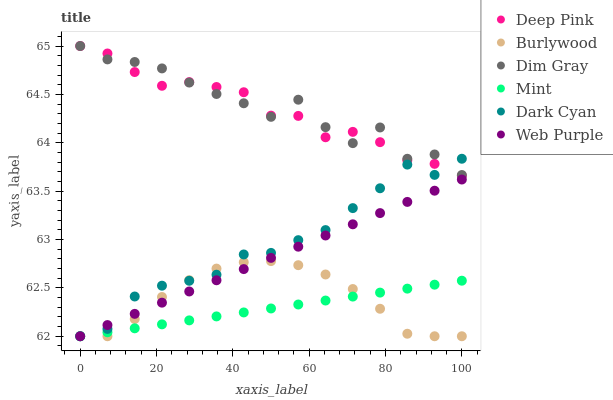Does Mint have the minimum area under the curve?
Answer yes or no. Yes. Does Dim Gray have the maximum area under the curve?
Answer yes or no. Yes. Does Burlywood have the minimum area under the curve?
Answer yes or no. No. Does Burlywood have the maximum area under the curve?
Answer yes or no. No. Is Mint the smoothest?
Answer yes or no. Yes. Is Dim Gray the roughest?
Answer yes or no. Yes. Is Burlywood the smoothest?
Answer yes or no. No. Is Burlywood the roughest?
Answer yes or no. No. Does Burlywood have the lowest value?
Answer yes or no. Yes. Does Deep Pink have the lowest value?
Answer yes or no. No. Does Deep Pink have the highest value?
Answer yes or no. Yes. Does Burlywood have the highest value?
Answer yes or no. No. Is Web Purple less than Deep Pink?
Answer yes or no. Yes. Is Deep Pink greater than Mint?
Answer yes or no. Yes. Does Web Purple intersect Dark Cyan?
Answer yes or no. Yes. Is Web Purple less than Dark Cyan?
Answer yes or no. No. Is Web Purple greater than Dark Cyan?
Answer yes or no. No. Does Web Purple intersect Deep Pink?
Answer yes or no. No. 